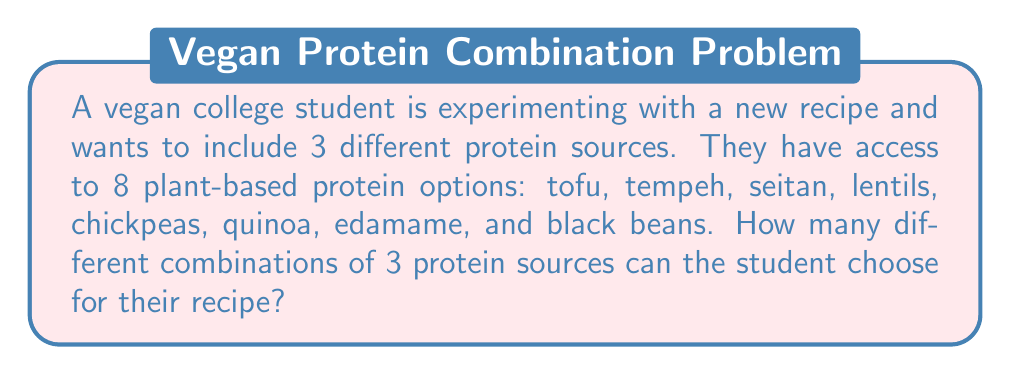Can you answer this question? To solve this problem, we need to use the combination formula. We are selecting 3 items from a set of 8, where the order doesn't matter (since we're just interested in which proteins are used, not the order they're added to the recipe).

The formula for combinations is:

$$ C(n,r) = \frac{n!}{r!(n-r)!} $$

Where:
$n$ is the total number of items to choose from (in this case, 8 protein options)
$r$ is the number of items being chosen (in this case, 3 protein sources)

Substituting our values:

$$ C(8,3) = \frac{8!}{3!(8-3)!} = \frac{8!}{3!5!} $$

Expanding this:

$$ \frac{8 \cdot 7 \cdot 6 \cdot 5!}{(3 \cdot 2 \cdot 1) \cdot 5!} $$

The $5!$ cancels out in the numerator and denominator:

$$ \frac{8 \cdot 7 \cdot 6}{3 \cdot 2 \cdot 1} = \frac{336}{6} = 56 $$

Therefore, there are 56 different combinations of 3 protein sources that the student can choose for their recipe.
Answer: 56 combinations 